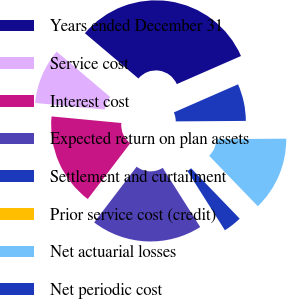Convert chart to OTSL. <chart><loc_0><loc_0><loc_500><loc_500><pie_chart><fcel>Years ended December 31<fcel>Service cost<fcel>Interest cost<fcel>Expected return on plan assets<fcel>Settlement and curtailment<fcel>Prior service cost (credit)<fcel>Net actuarial losses<fcel>Net periodic cost<nl><fcel>32.26%<fcel>9.68%<fcel>16.13%<fcel>19.35%<fcel>3.23%<fcel>0.0%<fcel>12.9%<fcel>6.45%<nl></chart> 